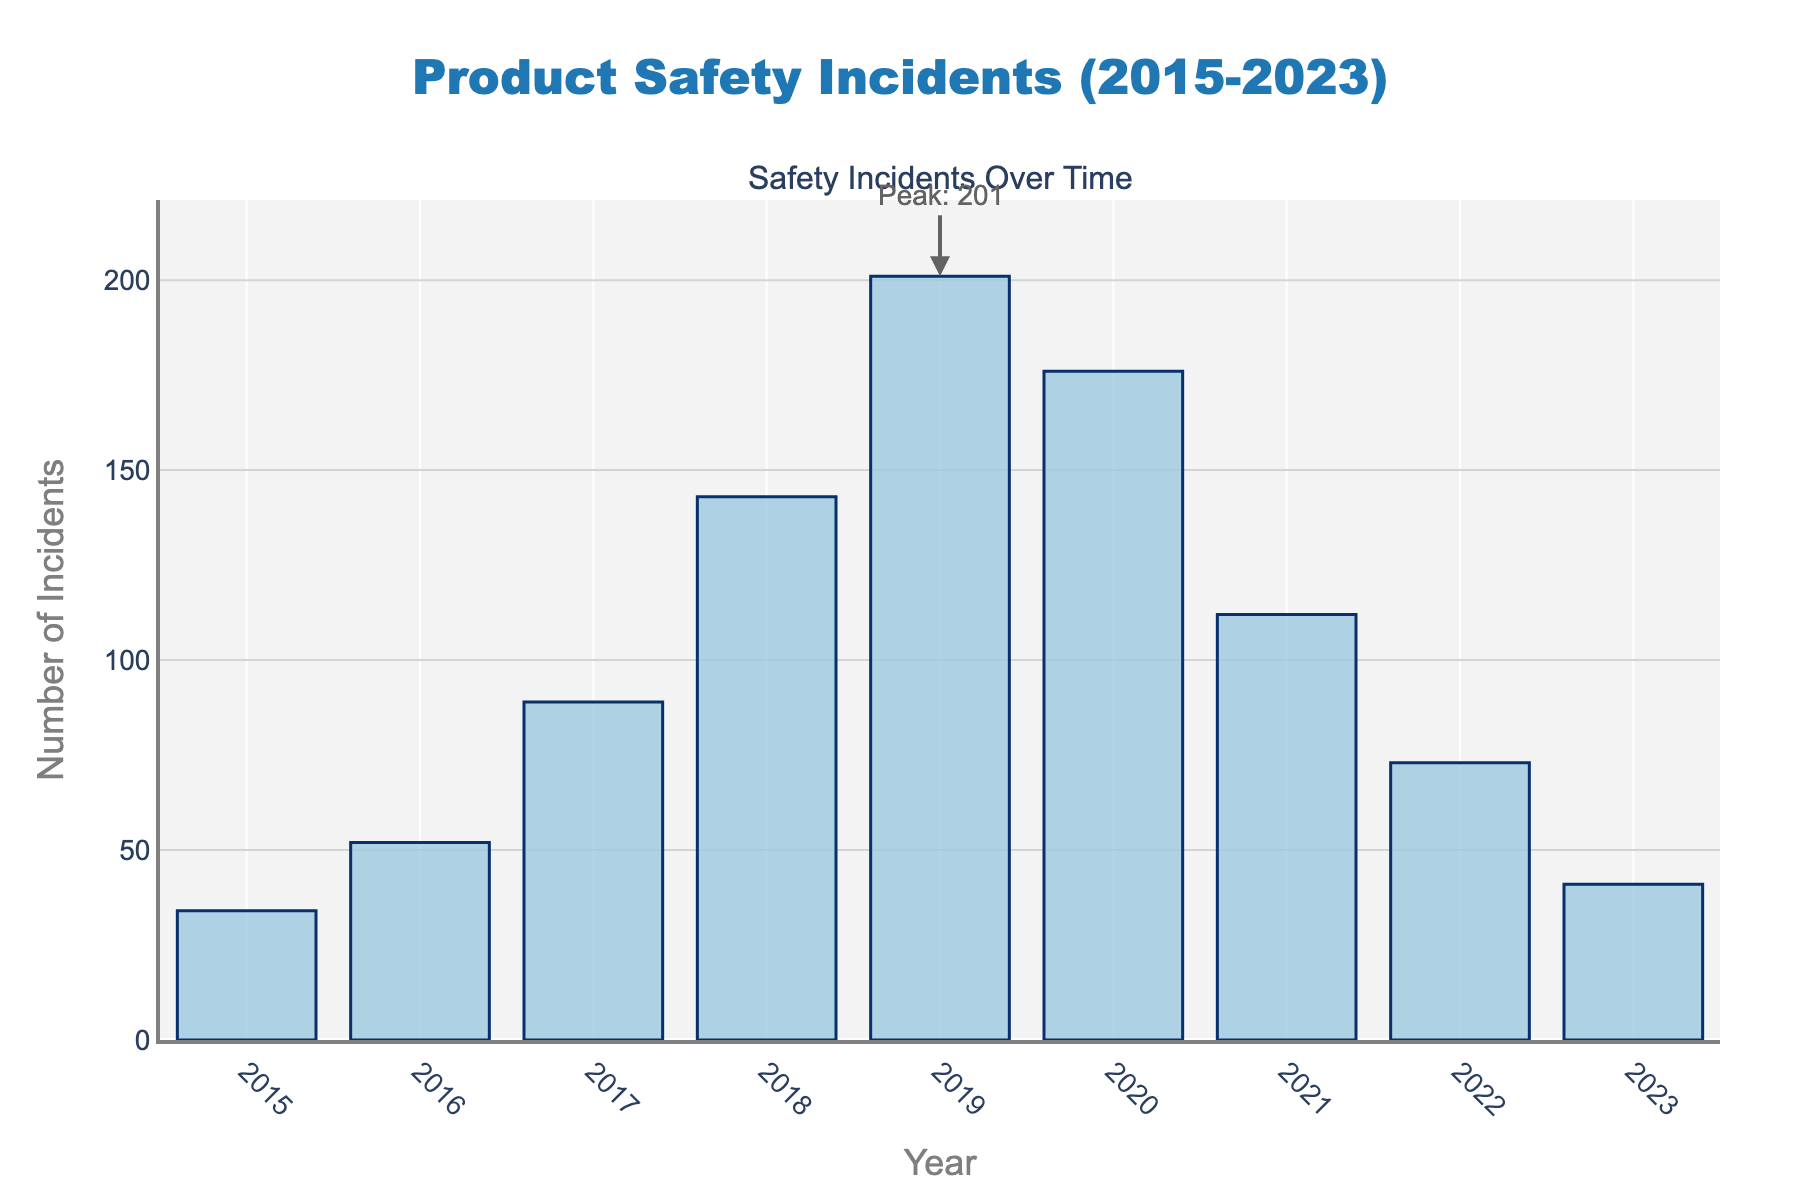What's the overall trend in the frequency of safety incidents over time? The frequency of safety incidents increased from 2015 to 2019, peaking in 2019, and then steadily decreased from 2019 to 2023.
Answer: Increased initially, peaked in 2019, then decreased Which year had the highest number of safety incidents? The year 2019 had the highest bar on the chart, indicating the maximum number of safety incidents.
Answer: 2019 How many safety incidents were reported in 2020? Referring to the bar for the year 2020, it indicates that there were 176 safety incidents.
Answer: 176 What is the difference in the number of safety incidents between 2017 and 2023? The number of incidents in 2017 was 89 and in 2023 was 41; subtracting 41 from 89 gives the difference. So, 89 - 41 = 48.
Answer: 48 Which year experienced a greater increase in the number of safety incidents: 2016 to 2017 or 2018 to 2019? Calculate the increase for each range: from 2016 to 2017, the increase is 89 - 52 = 37; from 2018 to 2019, the increase is 201 - 143 = 58. Thus, the increase from 2018 to 2019 is greater.
Answer: 2018 to 2019 What is the average number of incidents from 2015 to 2023? Sum the incidents from each year: 34 + 52 + 89 + 143 + 201 + 176 + 112 + 73 + 41 = 921. Divide this by the number of years (9): 921 / 9 = 102.33.
Answer: 102.33 What visual features highlight the peak year for safety incidents? The peak year, 2019, is highlighted with the highest bar on the chart and an annotation that reads 'Peak: 201'.
Answer: Highest bar and annotation By how much did the number of incidents decrease from the peak year to the subsequent year? The peak year (2019) had 201 incidents, and the subsequent year (2020) had 176 incidents. The decrease is 201 - 176 = 25.
Answer: 25 Is the number of incidents in 2022 more or less than half of the peak incidents in 2019? Half of the peak incidents in 2019 (201) is 201/2 = 100.5. The number of incidents in 2022 is 73, which is less than 100.5.
Answer: Less Between which consecutive years was the largest decline in the number of safety incidents observed? The largest decline is observed between 2019 and 2020. The number of incidents decreased from 201 to 176, a drop of 25.
Answer: Between 2019 and 2020 